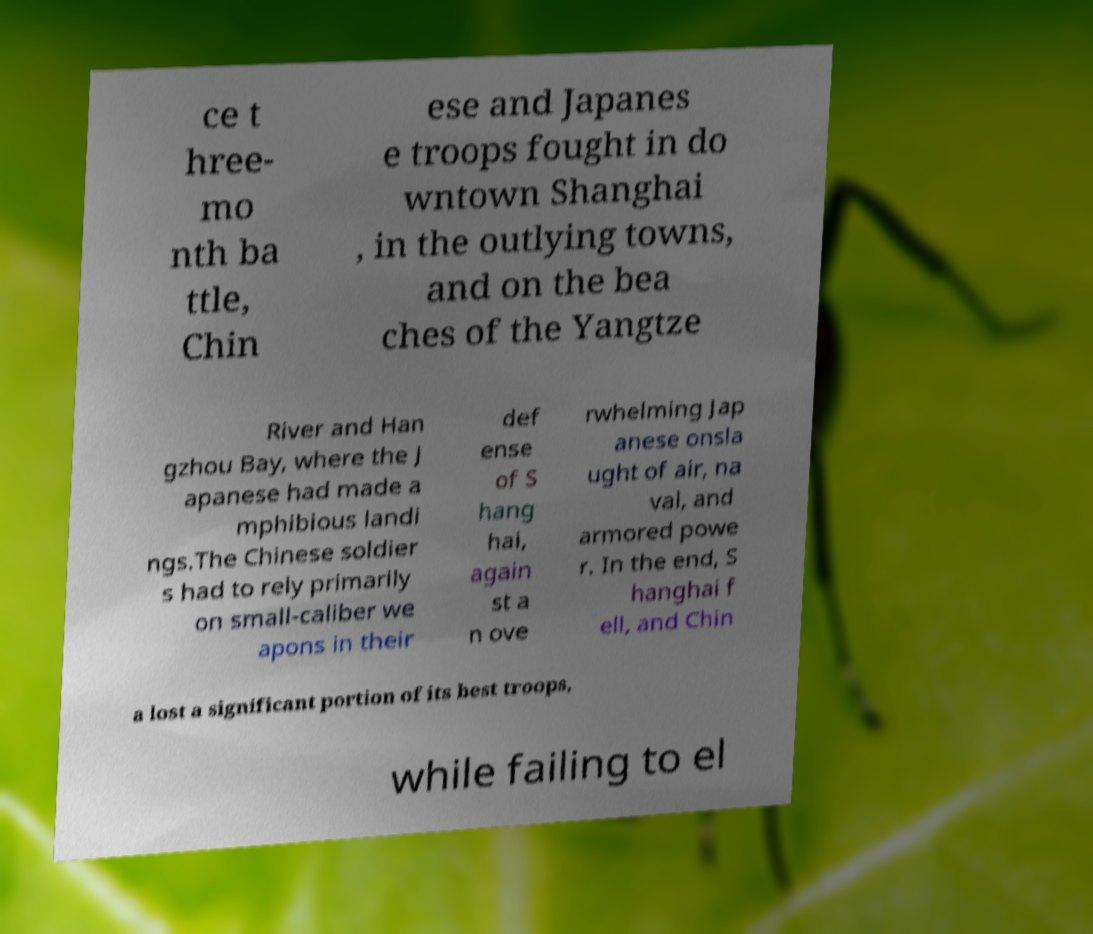Please read and relay the text visible in this image. What does it say? ce t hree- mo nth ba ttle, Chin ese and Japanes e troops fought in do wntown Shanghai , in the outlying towns, and on the bea ches of the Yangtze River and Han gzhou Bay, where the J apanese had made a mphibious landi ngs.The Chinese soldier s had to rely primarily on small-caliber we apons in their def ense of S hang hai, again st a n ove rwhelming Jap anese onsla ught of air, na val, and armored powe r. In the end, S hanghai f ell, and Chin a lost a significant portion of its best troops, while failing to el 